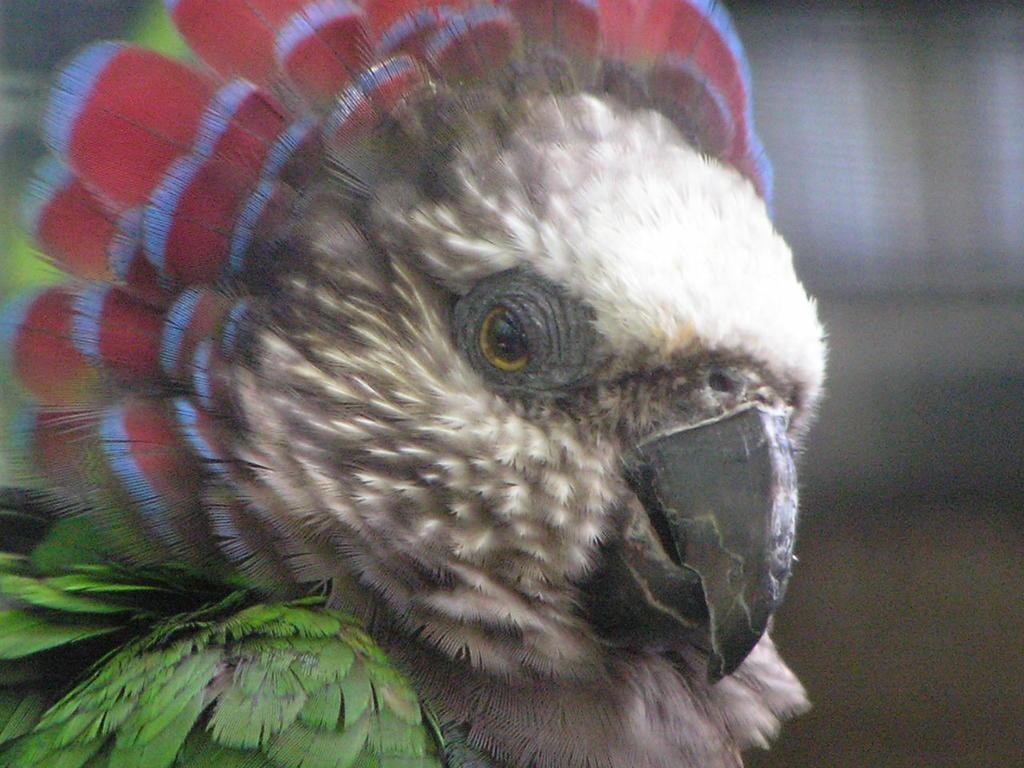Please provide a concise description of this image. In this image there is a parrot, in the background it is blurred. 